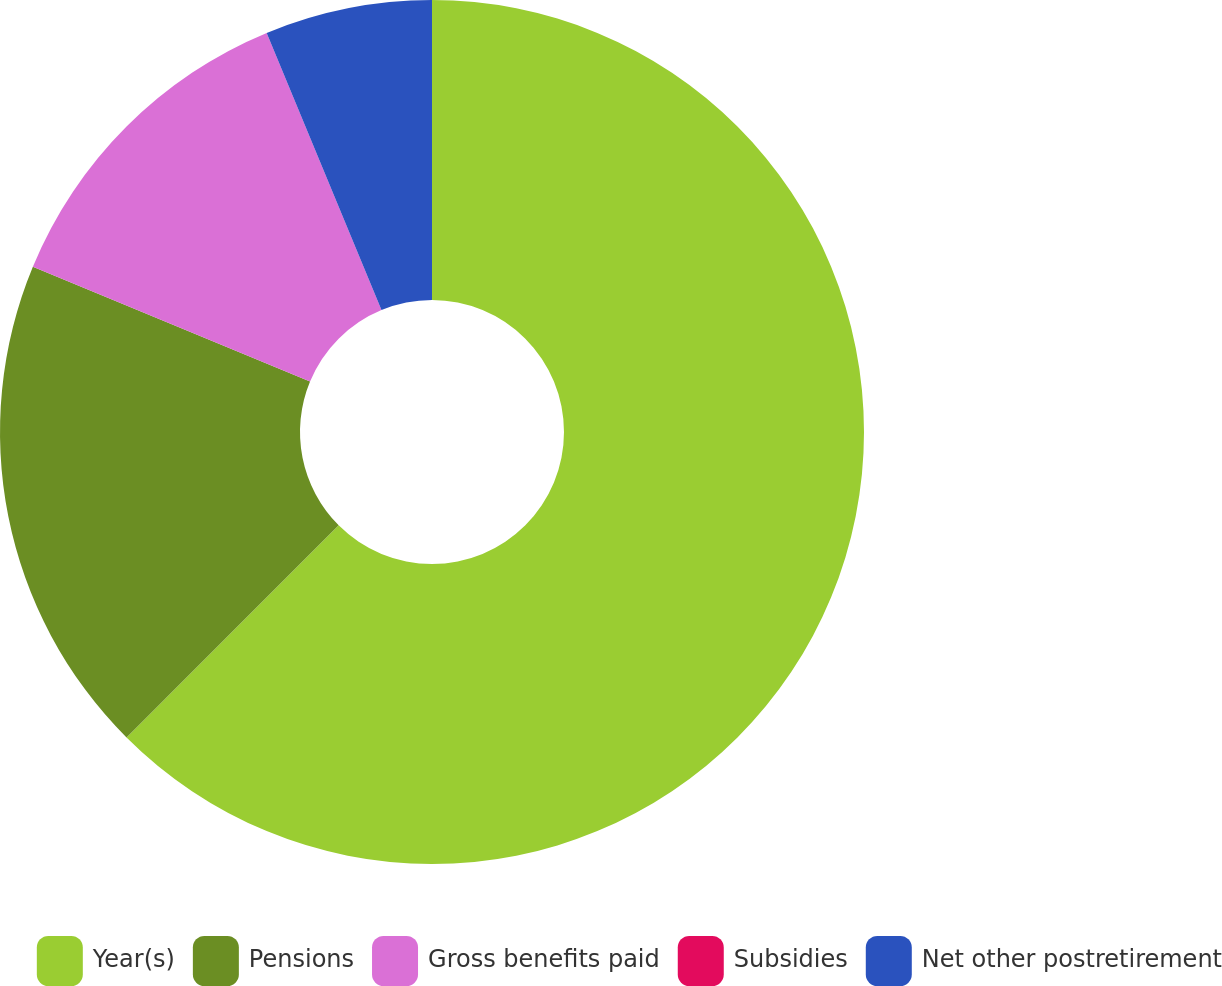Convert chart. <chart><loc_0><loc_0><loc_500><loc_500><pie_chart><fcel>Year(s)<fcel>Pensions<fcel>Gross benefits paid<fcel>Subsidies<fcel>Net other postretirement<nl><fcel>62.5%<fcel>18.75%<fcel>12.5%<fcel>0.0%<fcel>6.25%<nl></chart> 